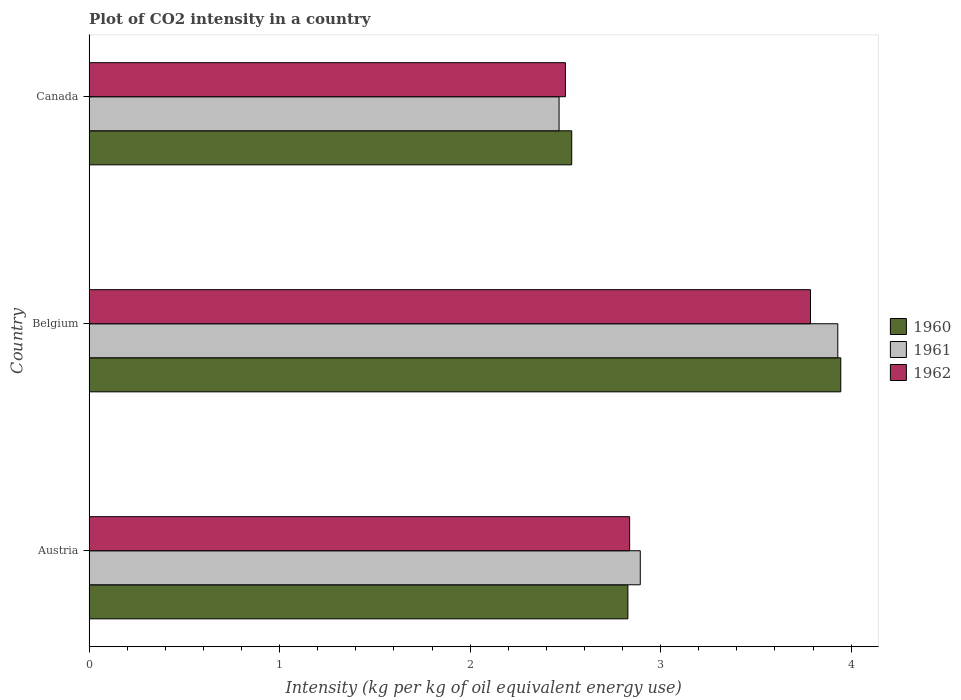How many different coloured bars are there?
Your response must be concise. 3. How many bars are there on the 3rd tick from the top?
Ensure brevity in your answer.  3. What is the label of the 2nd group of bars from the top?
Ensure brevity in your answer.  Belgium. What is the CO2 intensity in in 1960 in Belgium?
Your answer should be compact. 3.95. Across all countries, what is the maximum CO2 intensity in in 1961?
Make the answer very short. 3.93. Across all countries, what is the minimum CO2 intensity in in 1960?
Ensure brevity in your answer.  2.53. What is the total CO2 intensity in in 1960 in the graph?
Provide a short and direct response. 9.31. What is the difference between the CO2 intensity in in 1960 in Austria and that in Canada?
Make the answer very short. 0.29. What is the difference between the CO2 intensity in in 1962 in Canada and the CO2 intensity in in 1961 in Belgium?
Keep it short and to the point. -1.43. What is the average CO2 intensity in in 1962 per country?
Offer a very short reply. 3.04. What is the difference between the CO2 intensity in in 1962 and CO2 intensity in in 1960 in Canada?
Provide a short and direct response. -0.03. In how many countries, is the CO2 intensity in in 1962 greater than 1 kg?
Provide a succinct answer. 3. What is the ratio of the CO2 intensity in in 1962 in Austria to that in Belgium?
Offer a very short reply. 0.75. Is the CO2 intensity in in 1960 in Belgium less than that in Canada?
Offer a very short reply. No. Is the difference between the CO2 intensity in in 1962 in Austria and Belgium greater than the difference between the CO2 intensity in in 1960 in Austria and Belgium?
Your response must be concise. Yes. What is the difference between the highest and the second highest CO2 intensity in in 1960?
Provide a short and direct response. 1.12. What is the difference between the highest and the lowest CO2 intensity in in 1961?
Provide a succinct answer. 1.46. Is the sum of the CO2 intensity in in 1961 in Belgium and Canada greater than the maximum CO2 intensity in in 1962 across all countries?
Make the answer very short. Yes. Are all the bars in the graph horizontal?
Your response must be concise. Yes. How many countries are there in the graph?
Your answer should be very brief. 3. What is the difference between two consecutive major ticks on the X-axis?
Make the answer very short. 1. Does the graph contain grids?
Make the answer very short. No. Where does the legend appear in the graph?
Offer a terse response. Center right. What is the title of the graph?
Provide a short and direct response. Plot of CO2 intensity in a country. What is the label or title of the X-axis?
Provide a short and direct response. Intensity (kg per kg of oil equivalent energy use). What is the Intensity (kg per kg of oil equivalent energy use) in 1960 in Austria?
Ensure brevity in your answer.  2.83. What is the Intensity (kg per kg of oil equivalent energy use) of 1961 in Austria?
Make the answer very short. 2.89. What is the Intensity (kg per kg of oil equivalent energy use) in 1962 in Austria?
Offer a terse response. 2.84. What is the Intensity (kg per kg of oil equivalent energy use) in 1960 in Belgium?
Provide a short and direct response. 3.95. What is the Intensity (kg per kg of oil equivalent energy use) of 1961 in Belgium?
Your response must be concise. 3.93. What is the Intensity (kg per kg of oil equivalent energy use) in 1962 in Belgium?
Offer a very short reply. 3.79. What is the Intensity (kg per kg of oil equivalent energy use) of 1960 in Canada?
Provide a succinct answer. 2.53. What is the Intensity (kg per kg of oil equivalent energy use) of 1961 in Canada?
Your response must be concise. 2.47. What is the Intensity (kg per kg of oil equivalent energy use) of 1962 in Canada?
Your answer should be very brief. 2.5. Across all countries, what is the maximum Intensity (kg per kg of oil equivalent energy use) of 1960?
Make the answer very short. 3.95. Across all countries, what is the maximum Intensity (kg per kg of oil equivalent energy use) of 1961?
Give a very brief answer. 3.93. Across all countries, what is the maximum Intensity (kg per kg of oil equivalent energy use) of 1962?
Your answer should be very brief. 3.79. Across all countries, what is the minimum Intensity (kg per kg of oil equivalent energy use) in 1960?
Your answer should be very brief. 2.53. Across all countries, what is the minimum Intensity (kg per kg of oil equivalent energy use) in 1961?
Provide a succinct answer. 2.47. Across all countries, what is the minimum Intensity (kg per kg of oil equivalent energy use) of 1962?
Your answer should be very brief. 2.5. What is the total Intensity (kg per kg of oil equivalent energy use) of 1960 in the graph?
Your answer should be compact. 9.31. What is the total Intensity (kg per kg of oil equivalent energy use) of 1961 in the graph?
Make the answer very short. 9.29. What is the total Intensity (kg per kg of oil equivalent energy use) of 1962 in the graph?
Keep it short and to the point. 9.12. What is the difference between the Intensity (kg per kg of oil equivalent energy use) of 1960 in Austria and that in Belgium?
Your answer should be very brief. -1.12. What is the difference between the Intensity (kg per kg of oil equivalent energy use) in 1961 in Austria and that in Belgium?
Offer a terse response. -1.04. What is the difference between the Intensity (kg per kg of oil equivalent energy use) in 1962 in Austria and that in Belgium?
Ensure brevity in your answer.  -0.95. What is the difference between the Intensity (kg per kg of oil equivalent energy use) in 1960 in Austria and that in Canada?
Provide a succinct answer. 0.29. What is the difference between the Intensity (kg per kg of oil equivalent energy use) in 1961 in Austria and that in Canada?
Give a very brief answer. 0.43. What is the difference between the Intensity (kg per kg of oil equivalent energy use) of 1962 in Austria and that in Canada?
Ensure brevity in your answer.  0.34. What is the difference between the Intensity (kg per kg of oil equivalent energy use) of 1960 in Belgium and that in Canada?
Provide a short and direct response. 1.41. What is the difference between the Intensity (kg per kg of oil equivalent energy use) of 1961 in Belgium and that in Canada?
Your answer should be compact. 1.46. What is the difference between the Intensity (kg per kg of oil equivalent energy use) in 1962 in Belgium and that in Canada?
Give a very brief answer. 1.29. What is the difference between the Intensity (kg per kg of oil equivalent energy use) of 1960 in Austria and the Intensity (kg per kg of oil equivalent energy use) of 1961 in Belgium?
Provide a succinct answer. -1.1. What is the difference between the Intensity (kg per kg of oil equivalent energy use) in 1960 in Austria and the Intensity (kg per kg of oil equivalent energy use) in 1962 in Belgium?
Your answer should be compact. -0.96. What is the difference between the Intensity (kg per kg of oil equivalent energy use) of 1961 in Austria and the Intensity (kg per kg of oil equivalent energy use) of 1962 in Belgium?
Provide a short and direct response. -0.89. What is the difference between the Intensity (kg per kg of oil equivalent energy use) in 1960 in Austria and the Intensity (kg per kg of oil equivalent energy use) in 1961 in Canada?
Ensure brevity in your answer.  0.36. What is the difference between the Intensity (kg per kg of oil equivalent energy use) in 1960 in Austria and the Intensity (kg per kg of oil equivalent energy use) in 1962 in Canada?
Give a very brief answer. 0.33. What is the difference between the Intensity (kg per kg of oil equivalent energy use) in 1961 in Austria and the Intensity (kg per kg of oil equivalent energy use) in 1962 in Canada?
Keep it short and to the point. 0.39. What is the difference between the Intensity (kg per kg of oil equivalent energy use) of 1960 in Belgium and the Intensity (kg per kg of oil equivalent energy use) of 1961 in Canada?
Provide a short and direct response. 1.48. What is the difference between the Intensity (kg per kg of oil equivalent energy use) of 1960 in Belgium and the Intensity (kg per kg of oil equivalent energy use) of 1962 in Canada?
Give a very brief answer. 1.45. What is the difference between the Intensity (kg per kg of oil equivalent energy use) in 1961 in Belgium and the Intensity (kg per kg of oil equivalent energy use) in 1962 in Canada?
Offer a terse response. 1.43. What is the average Intensity (kg per kg of oil equivalent energy use) in 1960 per country?
Give a very brief answer. 3.1. What is the average Intensity (kg per kg of oil equivalent energy use) of 1961 per country?
Make the answer very short. 3.1. What is the average Intensity (kg per kg of oil equivalent energy use) in 1962 per country?
Make the answer very short. 3.04. What is the difference between the Intensity (kg per kg of oil equivalent energy use) of 1960 and Intensity (kg per kg of oil equivalent energy use) of 1961 in Austria?
Ensure brevity in your answer.  -0.07. What is the difference between the Intensity (kg per kg of oil equivalent energy use) in 1960 and Intensity (kg per kg of oil equivalent energy use) in 1962 in Austria?
Offer a terse response. -0.01. What is the difference between the Intensity (kg per kg of oil equivalent energy use) of 1961 and Intensity (kg per kg of oil equivalent energy use) of 1962 in Austria?
Offer a terse response. 0.06. What is the difference between the Intensity (kg per kg of oil equivalent energy use) in 1960 and Intensity (kg per kg of oil equivalent energy use) in 1961 in Belgium?
Make the answer very short. 0.02. What is the difference between the Intensity (kg per kg of oil equivalent energy use) of 1960 and Intensity (kg per kg of oil equivalent energy use) of 1962 in Belgium?
Make the answer very short. 0.16. What is the difference between the Intensity (kg per kg of oil equivalent energy use) of 1961 and Intensity (kg per kg of oil equivalent energy use) of 1962 in Belgium?
Your answer should be very brief. 0.14. What is the difference between the Intensity (kg per kg of oil equivalent energy use) of 1960 and Intensity (kg per kg of oil equivalent energy use) of 1961 in Canada?
Your answer should be compact. 0.07. What is the difference between the Intensity (kg per kg of oil equivalent energy use) of 1960 and Intensity (kg per kg of oil equivalent energy use) of 1962 in Canada?
Your answer should be very brief. 0.03. What is the difference between the Intensity (kg per kg of oil equivalent energy use) of 1961 and Intensity (kg per kg of oil equivalent energy use) of 1962 in Canada?
Provide a succinct answer. -0.03. What is the ratio of the Intensity (kg per kg of oil equivalent energy use) of 1960 in Austria to that in Belgium?
Offer a terse response. 0.72. What is the ratio of the Intensity (kg per kg of oil equivalent energy use) of 1961 in Austria to that in Belgium?
Ensure brevity in your answer.  0.74. What is the ratio of the Intensity (kg per kg of oil equivalent energy use) of 1962 in Austria to that in Belgium?
Provide a succinct answer. 0.75. What is the ratio of the Intensity (kg per kg of oil equivalent energy use) in 1960 in Austria to that in Canada?
Offer a terse response. 1.12. What is the ratio of the Intensity (kg per kg of oil equivalent energy use) in 1961 in Austria to that in Canada?
Provide a succinct answer. 1.17. What is the ratio of the Intensity (kg per kg of oil equivalent energy use) of 1962 in Austria to that in Canada?
Provide a succinct answer. 1.13. What is the ratio of the Intensity (kg per kg of oil equivalent energy use) of 1960 in Belgium to that in Canada?
Provide a short and direct response. 1.56. What is the ratio of the Intensity (kg per kg of oil equivalent energy use) in 1961 in Belgium to that in Canada?
Provide a short and direct response. 1.59. What is the ratio of the Intensity (kg per kg of oil equivalent energy use) in 1962 in Belgium to that in Canada?
Ensure brevity in your answer.  1.51. What is the difference between the highest and the second highest Intensity (kg per kg of oil equivalent energy use) of 1960?
Ensure brevity in your answer.  1.12. What is the difference between the highest and the second highest Intensity (kg per kg of oil equivalent energy use) of 1961?
Provide a succinct answer. 1.04. What is the difference between the highest and the second highest Intensity (kg per kg of oil equivalent energy use) of 1962?
Keep it short and to the point. 0.95. What is the difference between the highest and the lowest Intensity (kg per kg of oil equivalent energy use) in 1960?
Offer a very short reply. 1.41. What is the difference between the highest and the lowest Intensity (kg per kg of oil equivalent energy use) of 1961?
Make the answer very short. 1.46. What is the difference between the highest and the lowest Intensity (kg per kg of oil equivalent energy use) of 1962?
Provide a succinct answer. 1.29. 